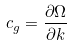<formula> <loc_0><loc_0><loc_500><loc_500>c _ { g } = \frac { \partial \Omega } { \partial k }</formula> 